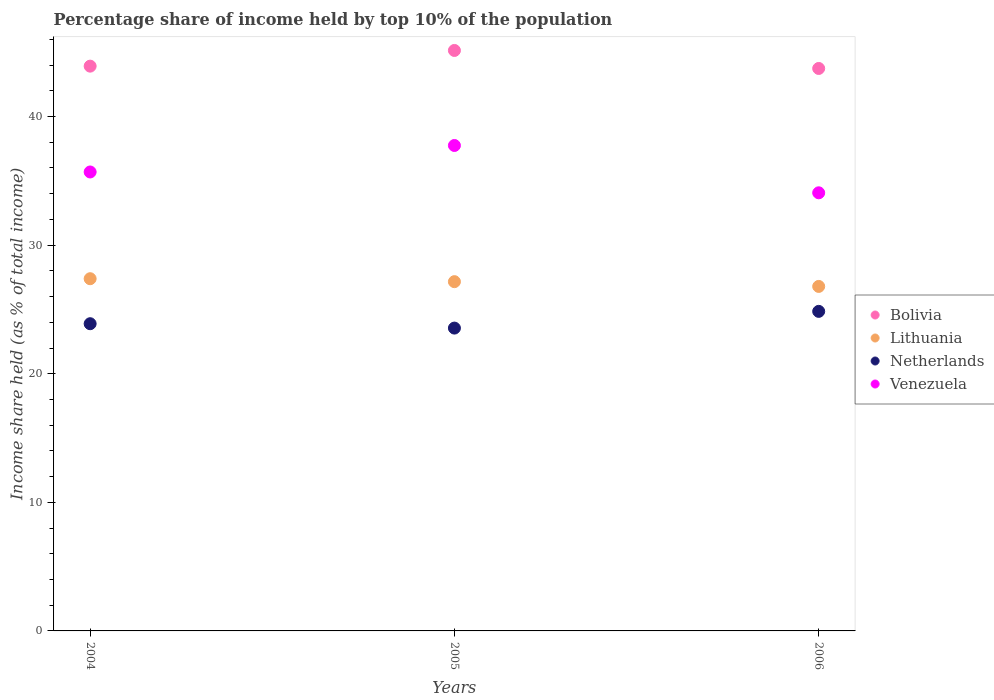How many different coloured dotlines are there?
Keep it short and to the point. 4. What is the percentage share of income held by top 10% of the population in Netherlands in 2005?
Keep it short and to the point. 23.55. Across all years, what is the maximum percentage share of income held by top 10% of the population in Netherlands?
Provide a short and direct response. 24.85. Across all years, what is the minimum percentage share of income held by top 10% of the population in Bolivia?
Your response must be concise. 43.74. In which year was the percentage share of income held by top 10% of the population in Netherlands minimum?
Keep it short and to the point. 2005. What is the total percentage share of income held by top 10% of the population in Bolivia in the graph?
Your response must be concise. 132.8. What is the difference between the percentage share of income held by top 10% of the population in Venezuela in 2004 and that in 2006?
Make the answer very short. 1.62. What is the difference between the percentage share of income held by top 10% of the population in Bolivia in 2006 and the percentage share of income held by top 10% of the population in Lithuania in 2004?
Give a very brief answer. 16.35. What is the average percentage share of income held by top 10% of the population in Bolivia per year?
Provide a succinct answer. 44.27. In the year 2006, what is the difference between the percentage share of income held by top 10% of the population in Lithuania and percentage share of income held by top 10% of the population in Netherlands?
Provide a succinct answer. 1.94. In how many years, is the percentage share of income held by top 10% of the population in Venezuela greater than 26 %?
Provide a succinct answer. 3. What is the ratio of the percentage share of income held by top 10% of the population in Lithuania in 2004 to that in 2005?
Offer a very short reply. 1.01. Is the percentage share of income held by top 10% of the population in Lithuania in 2005 less than that in 2006?
Offer a terse response. No. Is the difference between the percentage share of income held by top 10% of the population in Lithuania in 2004 and 2005 greater than the difference between the percentage share of income held by top 10% of the population in Netherlands in 2004 and 2005?
Give a very brief answer. No. What is the difference between the highest and the second highest percentage share of income held by top 10% of the population in Bolivia?
Offer a very short reply. 1.22. What is the difference between the highest and the lowest percentage share of income held by top 10% of the population in Bolivia?
Offer a very short reply. 1.4. In how many years, is the percentage share of income held by top 10% of the population in Venezuela greater than the average percentage share of income held by top 10% of the population in Venezuela taken over all years?
Your answer should be compact. 1. Is it the case that in every year, the sum of the percentage share of income held by top 10% of the population in Netherlands and percentage share of income held by top 10% of the population in Bolivia  is greater than the sum of percentage share of income held by top 10% of the population in Venezuela and percentage share of income held by top 10% of the population in Lithuania?
Give a very brief answer. Yes. Is it the case that in every year, the sum of the percentage share of income held by top 10% of the population in Netherlands and percentage share of income held by top 10% of the population in Venezuela  is greater than the percentage share of income held by top 10% of the population in Bolivia?
Your response must be concise. Yes. Does the percentage share of income held by top 10% of the population in Netherlands monotonically increase over the years?
Ensure brevity in your answer.  No. Is the percentage share of income held by top 10% of the population in Bolivia strictly greater than the percentage share of income held by top 10% of the population in Lithuania over the years?
Offer a very short reply. Yes. How many dotlines are there?
Ensure brevity in your answer.  4. How many years are there in the graph?
Your answer should be compact. 3. What is the difference between two consecutive major ticks on the Y-axis?
Your answer should be compact. 10. Does the graph contain any zero values?
Offer a terse response. No. How many legend labels are there?
Provide a short and direct response. 4. How are the legend labels stacked?
Your response must be concise. Vertical. What is the title of the graph?
Your response must be concise. Percentage share of income held by top 10% of the population. Does "Fiji" appear as one of the legend labels in the graph?
Offer a terse response. No. What is the label or title of the Y-axis?
Keep it short and to the point. Income share held (as % of total income). What is the Income share held (as % of total income) in Bolivia in 2004?
Ensure brevity in your answer.  43.92. What is the Income share held (as % of total income) of Lithuania in 2004?
Offer a very short reply. 27.39. What is the Income share held (as % of total income) in Netherlands in 2004?
Keep it short and to the point. 23.89. What is the Income share held (as % of total income) in Venezuela in 2004?
Make the answer very short. 35.69. What is the Income share held (as % of total income) of Bolivia in 2005?
Keep it short and to the point. 45.14. What is the Income share held (as % of total income) of Lithuania in 2005?
Provide a short and direct response. 27.16. What is the Income share held (as % of total income) of Netherlands in 2005?
Make the answer very short. 23.55. What is the Income share held (as % of total income) in Venezuela in 2005?
Your answer should be compact. 37.75. What is the Income share held (as % of total income) in Bolivia in 2006?
Your response must be concise. 43.74. What is the Income share held (as % of total income) of Lithuania in 2006?
Give a very brief answer. 26.79. What is the Income share held (as % of total income) in Netherlands in 2006?
Give a very brief answer. 24.85. What is the Income share held (as % of total income) in Venezuela in 2006?
Give a very brief answer. 34.07. Across all years, what is the maximum Income share held (as % of total income) in Bolivia?
Make the answer very short. 45.14. Across all years, what is the maximum Income share held (as % of total income) in Lithuania?
Offer a very short reply. 27.39. Across all years, what is the maximum Income share held (as % of total income) of Netherlands?
Your answer should be very brief. 24.85. Across all years, what is the maximum Income share held (as % of total income) in Venezuela?
Your response must be concise. 37.75. Across all years, what is the minimum Income share held (as % of total income) of Bolivia?
Your answer should be compact. 43.74. Across all years, what is the minimum Income share held (as % of total income) of Lithuania?
Give a very brief answer. 26.79. Across all years, what is the minimum Income share held (as % of total income) in Netherlands?
Provide a succinct answer. 23.55. Across all years, what is the minimum Income share held (as % of total income) of Venezuela?
Offer a terse response. 34.07. What is the total Income share held (as % of total income) in Bolivia in the graph?
Provide a short and direct response. 132.8. What is the total Income share held (as % of total income) in Lithuania in the graph?
Provide a succinct answer. 81.34. What is the total Income share held (as % of total income) of Netherlands in the graph?
Give a very brief answer. 72.29. What is the total Income share held (as % of total income) in Venezuela in the graph?
Offer a terse response. 107.51. What is the difference between the Income share held (as % of total income) in Bolivia in 2004 and that in 2005?
Your response must be concise. -1.22. What is the difference between the Income share held (as % of total income) of Lithuania in 2004 and that in 2005?
Your answer should be compact. 0.23. What is the difference between the Income share held (as % of total income) in Netherlands in 2004 and that in 2005?
Ensure brevity in your answer.  0.34. What is the difference between the Income share held (as % of total income) of Venezuela in 2004 and that in 2005?
Offer a very short reply. -2.06. What is the difference between the Income share held (as % of total income) of Bolivia in 2004 and that in 2006?
Offer a terse response. 0.18. What is the difference between the Income share held (as % of total income) in Lithuania in 2004 and that in 2006?
Offer a very short reply. 0.6. What is the difference between the Income share held (as % of total income) in Netherlands in 2004 and that in 2006?
Keep it short and to the point. -0.96. What is the difference between the Income share held (as % of total income) of Venezuela in 2004 and that in 2006?
Offer a terse response. 1.62. What is the difference between the Income share held (as % of total income) of Lithuania in 2005 and that in 2006?
Make the answer very short. 0.37. What is the difference between the Income share held (as % of total income) in Venezuela in 2005 and that in 2006?
Offer a very short reply. 3.68. What is the difference between the Income share held (as % of total income) of Bolivia in 2004 and the Income share held (as % of total income) of Lithuania in 2005?
Offer a terse response. 16.76. What is the difference between the Income share held (as % of total income) in Bolivia in 2004 and the Income share held (as % of total income) in Netherlands in 2005?
Keep it short and to the point. 20.37. What is the difference between the Income share held (as % of total income) of Bolivia in 2004 and the Income share held (as % of total income) of Venezuela in 2005?
Your response must be concise. 6.17. What is the difference between the Income share held (as % of total income) of Lithuania in 2004 and the Income share held (as % of total income) of Netherlands in 2005?
Offer a very short reply. 3.84. What is the difference between the Income share held (as % of total income) of Lithuania in 2004 and the Income share held (as % of total income) of Venezuela in 2005?
Offer a very short reply. -10.36. What is the difference between the Income share held (as % of total income) in Netherlands in 2004 and the Income share held (as % of total income) in Venezuela in 2005?
Provide a succinct answer. -13.86. What is the difference between the Income share held (as % of total income) in Bolivia in 2004 and the Income share held (as % of total income) in Lithuania in 2006?
Provide a succinct answer. 17.13. What is the difference between the Income share held (as % of total income) in Bolivia in 2004 and the Income share held (as % of total income) in Netherlands in 2006?
Give a very brief answer. 19.07. What is the difference between the Income share held (as % of total income) in Bolivia in 2004 and the Income share held (as % of total income) in Venezuela in 2006?
Offer a terse response. 9.85. What is the difference between the Income share held (as % of total income) of Lithuania in 2004 and the Income share held (as % of total income) of Netherlands in 2006?
Offer a very short reply. 2.54. What is the difference between the Income share held (as % of total income) of Lithuania in 2004 and the Income share held (as % of total income) of Venezuela in 2006?
Ensure brevity in your answer.  -6.68. What is the difference between the Income share held (as % of total income) of Netherlands in 2004 and the Income share held (as % of total income) of Venezuela in 2006?
Make the answer very short. -10.18. What is the difference between the Income share held (as % of total income) in Bolivia in 2005 and the Income share held (as % of total income) in Lithuania in 2006?
Your answer should be compact. 18.35. What is the difference between the Income share held (as % of total income) of Bolivia in 2005 and the Income share held (as % of total income) of Netherlands in 2006?
Your answer should be very brief. 20.29. What is the difference between the Income share held (as % of total income) in Bolivia in 2005 and the Income share held (as % of total income) in Venezuela in 2006?
Give a very brief answer. 11.07. What is the difference between the Income share held (as % of total income) in Lithuania in 2005 and the Income share held (as % of total income) in Netherlands in 2006?
Your answer should be very brief. 2.31. What is the difference between the Income share held (as % of total income) in Lithuania in 2005 and the Income share held (as % of total income) in Venezuela in 2006?
Your response must be concise. -6.91. What is the difference between the Income share held (as % of total income) of Netherlands in 2005 and the Income share held (as % of total income) of Venezuela in 2006?
Provide a short and direct response. -10.52. What is the average Income share held (as % of total income) of Bolivia per year?
Provide a short and direct response. 44.27. What is the average Income share held (as % of total income) of Lithuania per year?
Provide a short and direct response. 27.11. What is the average Income share held (as % of total income) of Netherlands per year?
Ensure brevity in your answer.  24.1. What is the average Income share held (as % of total income) in Venezuela per year?
Provide a short and direct response. 35.84. In the year 2004, what is the difference between the Income share held (as % of total income) in Bolivia and Income share held (as % of total income) in Lithuania?
Provide a succinct answer. 16.53. In the year 2004, what is the difference between the Income share held (as % of total income) of Bolivia and Income share held (as % of total income) of Netherlands?
Provide a short and direct response. 20.03. In the year 2004, what is the difference between the Income share held (as % of total income) of Bolivia and Income share held (as % of total income) of Venezuela?
Ensure brevity in your answer.  8.23. In the year 2004, what is the difference between the Income share held (as % of total income) of Lithuania and Income share held (as % of total income) of Netherlands?
Provide a short and direct response. 3.5. In the year 2004, what is the difference between the Income share held (as % of total income) of Lithuania and Income share held (as % of total income) of Venezuela?
Your answer should be compact. -8.3. In the year 2004, what is the difference between the Income share held (as % of total income) of Netherlands and Income share held (as % of total income) of Venezuela?
Keep it short and to the point. -11.8. In the year 2005, what is the difference between the Income share held (as % of total income) of Bolivia and Income share held (as % of total income) of Lithuania?
Make the answer very short. 17.98. In the year 2005, what is the difference between the Income share held (as % of total income) in Bolivia and Income share held (as % of total income) in Netherlands?
Your answer should be very brief. 21.59. In the year 2005, what is the difference between the Income share held (as % of total income) in Bolivia and Income share held (as % of total income) in Venezuela?
Provide a short and direct response. 7.39. In the year 2005, what is the difference between the Income share held (as % of total income) of Lithuania and Income share held (as % of total income) of Netherlands?
Offer a terse response. 3.61. In the year 2005, what is the difference between the Income share held (as % of total income) in Lithuania and Income share held (as % of total income) in Venezuela?
Your response must be concise. -10.59. In the year 2006, what is the difference between the Income share held (as % of total income) of Bolivia and Income share held (as % of total income) of Lithuania?
Your answer should be compact. 16.95. In the year 2006, what is the difference between the Income share held (as % of total income) in Bolivia and Income share held (as % of total income) in Netherlands?
Provide a succinct answer. 18.89. In the year 2006, what is the difference between the Income share held (as % of total income) of Bolivia and Income share held (as % of total income) of Venezuela?
Your answer should be compact. 9.67. In the year 2006, what is the difference between the Income share held (as % of total income) in Lithuania and Income share held (as % of total income) in Netherlands?
Your answer should be compact. 1.94. In the year 2006, what is the difference between the Income share held (as % of total income) of Lithuania and Income share held (as % of total income) of Venezuela?
Provide a succinct answer. -7.28. In the year 2006, what is the difference between the Income share held (as % of total income) of Netherlands and Income share held (as % of total income) of Venezuela?
Make the answer very short. -9.22. What is the ratio of the Income share held (as % of total income) in Bolivia in 2004 to that in 2005?
Ensure brevity in your answer.  0.97. What is the ratio of the Income share held (as % of total income) in Lithuania in 2004 to that in 2005?
Keep it short and to the point. 1.01. What is the ratio of the Income share held (as % of total income) in Netherlands in 2004 to that in 2005?
Keep it short and to the point. 1.01. What is the ratio of the Income share held (as % of total income) in Venezuela in 2004 to that in 2005?
Your answer should be compact. 0.95. What is the ratio of the Income share held (as % of total income) in Bolivia in 2004 to that in 2006?
Give a very brief answer. 1. What is the ratio of the Income share held (as % of total income) in Lithuania in 2004 to that in 2006?
Your response must be concise. 1.02. What is the ratio of the Income share held (as % of total income) in Netherlands in 2004 to that in 2006?
Offer a terse response. 0.96. What is the ratio of the Income share held (as % of total income) of Venezuela in 2004 to that in 2006?
Provide a short and direct response. 1.05. What is the ratio of the Income share held (as % of total income) of Bolivia in 2005 to that in 2006?
Keep it short and to the point. 1.03. What is the ratio of the Income share held (as % of total income) in Lithuania in 2005 to that in 2006?
Provide a succinct answer. 1.01. What is the ratio of the Income share held (as % of total income) of Netherlands in 2005 to that in 2006?
Provide a short and direct response. 0.95. What is the ratio of the Income share held (as % of total income) of Venezuela in 2005 to that in 2006?
Ensure brevity in your answer.  1.11. What is the difference between the highest and the second highest Income share held (as % of total income) in Bolivia?
Your answer should be compact. 1.22. What is the difference between the highest and the second highest Income share held (as % of total income) of Lithuania?
Ensure brevity in your answer.  0.23. What is the difference between the highest and the second highest Income share held (as % of total income) of Venezuela?
Offer a very short reply. 2.06. What is the difference between the highest and the lowest Income share held (as % of total income) in Lithuania?
Make the answer very short. 0.6. What is the difference between the highest and the lowest Income share held (as % of total income) in Netherlands?
Provide a short and direct response. 1.3. What is the difference between the highest and the lowest Income share held (as % of total income) of Venezuela?
Your answer should be compact. 3.68. 